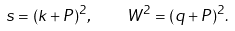<formula> <loc_0><loc_0><loc_500><loc_500>s = ( k + P ) ^ { 2 } , \quad W ^ { 2 } = ( q + P ) ^ { 2 } .</formula> 